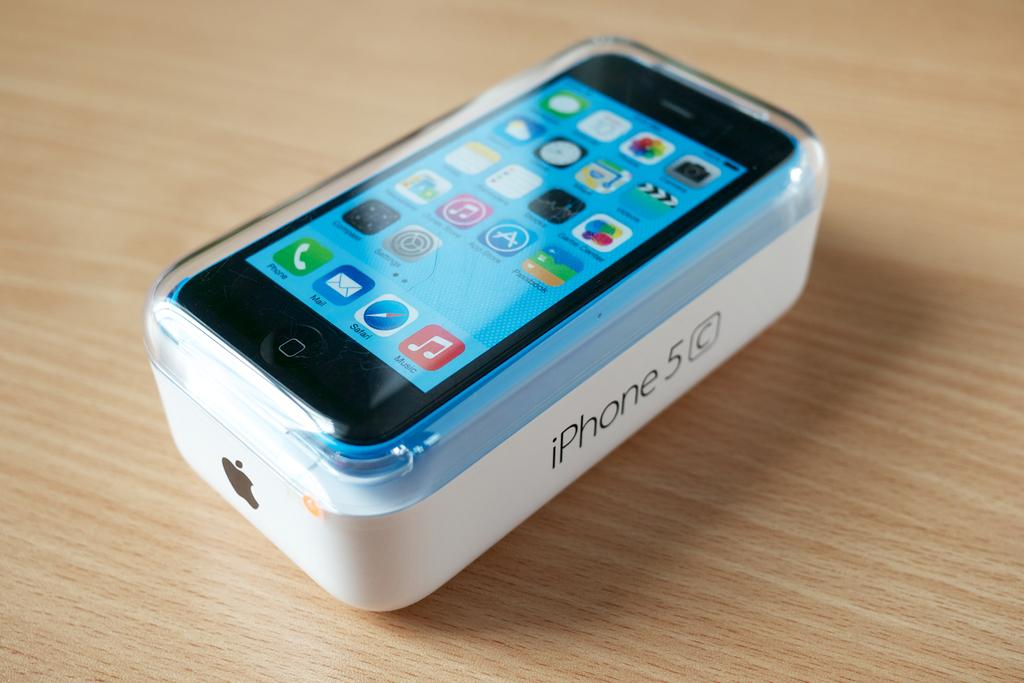<image>
Describe the image concisely. An iPhone 5 in its case sits on a desk. 